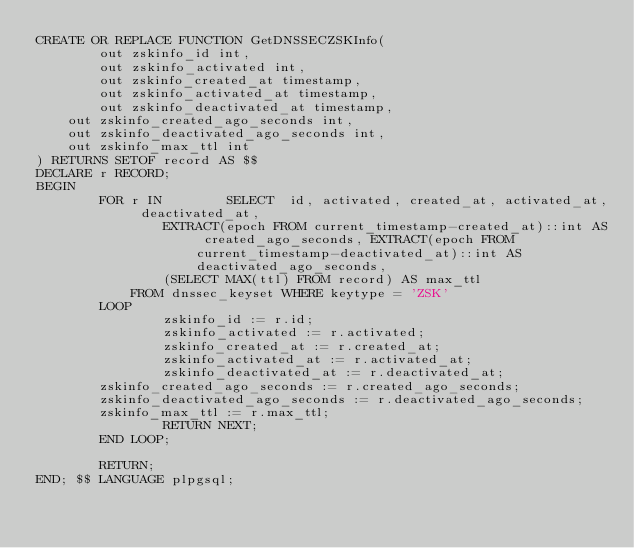<code> <loc_0><loc_0><loc_500><loc_500><_SQL_>CREATE OR REPLACE FUNCTION GetDNSSECZSKInfo(
        out zskinfo_id int,
        out zskinfo_activated int,
        out zskinfo_created_at timestamp,
        out zskinfo_activated_at timestamp,
        out zskinfo_deactivated_at timestamp,
	out zskinfo_created_ago_seconds int,
	out zskinfo_deactivated_ago_seconds int,
	out zskinfo_max_ttl int
) RETURNS SETOF record AS $$
DECLARE r RECORD;
BEGIN
        FOR r IN        SELECT	id, activated, created_at, activated_at, deactivated_at,
				EXTRACT(epoch FROM current_timestamp-created_at)::int AS created_ago_seconds, EXTRACT(epoch FROM current_timestamp-deactivated_at)::int AS deactivated_ago_seconds,
				(SELECT MAX(ttl) FROM record) AS max_ttl
			FROM dnssec_keyset WHERE keytype = 'ZSK'
        LOOP
                zskinfo_id := r.id;
                zskinfo_activated := r.activated;
                zskinfo_created_at := r.created_at;
                zskinfo_activated_at := r.activated_at;
                zskinfo_deactivated_at := r.deactivated_at;
		zskinfo_created_ago_seconds := r.created_ago_seconds;
		zskinfo_deactivated_ago_seconds := r.deactivated_ago_seconds;
		zskinfo_max_ttl := r.max_ttl;
                RETURN NEXT;
        END LOOP;

        RETURN;
END; $$ LANGUAGE plpgsql;

</code> 